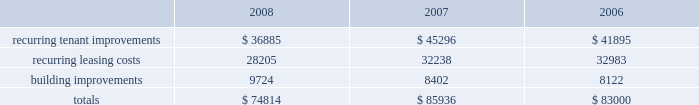Customary conditions .
We will retain a 20% ( 20 % ) equity interest in the joint venture .
As of december 31 , 2008 , the joint venture has acquired seven properties from us and we received year-to-date net sale proceeds and financing distributions of approximately $ 251.6 million .
In january 2008 , we sold a tract of land to an unconsolidated joint venture in which we hold a 50% ( 50 % ) equity interest and received a distribution , commensurate to our partner 2019s 50% ( 50 % ) ownership interest , of approximately $ 38.3 million .
In november 2008 , that unconsolidated joint venture entered a loan agreement with a consortium of banks and distributed a portion of the loan proceeds to us and our partner , with our share of the distribution totaling $ 20.4 million .
Uses of liquidity our principal uses of liquidity include the following : 2022 property investment ; 2022 recurring leasing/capital costs ; 2022 dividends and distributions to shareholders and unitholders ; 2022 long-term debt maturities ; 2022 opportunistic repurchases of outstanding debt ; and 2022 other contractual obligations .
Property investment we evaluate development and acquisition opportunities based upon market outlook , supply and long-term growth potential .
Our ability to make future property investments is dependent upon our continued access to our longer-term sources of liquidity including the issuances of debt or equity securities as well as disposing of selected properties .
In light of current economic conditions , management continues to evaluate our investment priorities and we are limiting new development expenditures .
Recurring expenditures one of our principal uses of our liquidity is to fund the recurring leasing/capital expenditures of our real estate investments .
The following is a summary of our recurring capital expenditures for the years ended december 31 , 2008 , 2007 and 2006 , respectively ( in thousands ) : .
Dividends and distributions in order to qualify as a reit for federal income tax purposes , we must currently distribute at least 90% ( 90 % ) of our taxable income to shareholders .
Because depreciation is a non-cash expense , cash flow will typically be greater than operating income .
We paid dividends per share of $ 1.93 , $ 1.91 and $ 1.89 for the years ended december 31 , 2008 , 2007 and 2006 , respectively .
We expect to continue to distribute taxable earnings to meet the requirements to maintain our reit status .
However , distributions are declared at the discretion of our board of directors and are subject to actual cash available for distribution , our financial condition , capital requirements and such other factors as our board of directors deems relevant . in january 2009 , our board of directors resolved to decrease our annual dividend from $ 1.94 per share to $ 1.00 per share in order to retain additional cash to help meet our capital needs .
We anticipate retaining additional cash of approximately $ 145.2 million per year , when compared to an annual dividend of $ 1.94 per share , as the result of this action .
At december 31 , 2008 we had six series of preferred shares outstanding .
The annual dividend rates on our preferred shares range between 6.5% ( 6.5 % ) and 8.375% ( 8.375 % ) and are paid in arrears quarterly. .
What is the percent change in total recurring capital expenditures from 2006 to 2007? 
Computations: (((85936 - 83000) / 83000) * 100)
Answer: 3.53735. 